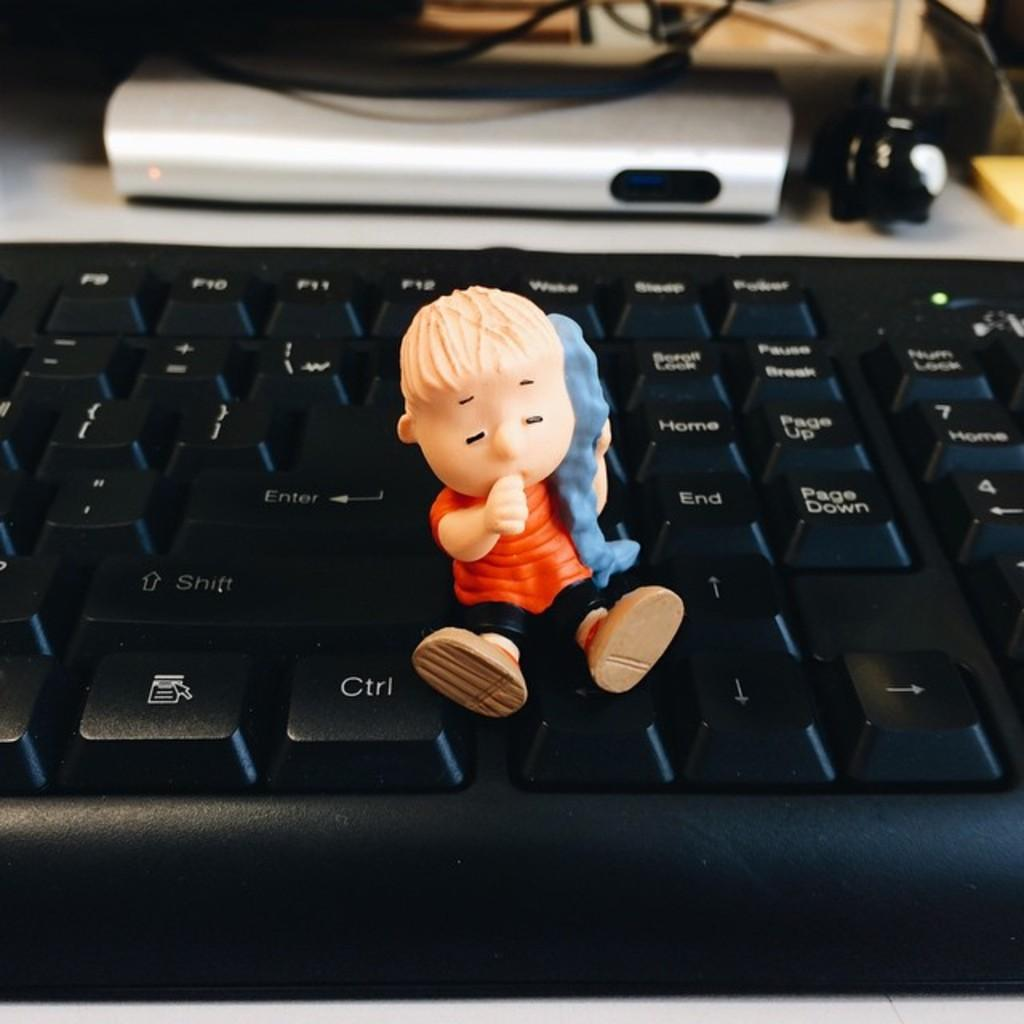Provide a one-sentence caption for the provided image. The small cartoon character children's toy sits on the keyboard like he's going to hit the [Ctrl] like a gas pedal. 